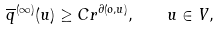Convert formula to latex. <formula><loc_0><loc_0><loc_500><loc_500>\overline { q } ^ { ( \infty ) } ( u ) \geq C r ^ { \partial ( o , u ) } , \quad u \in V ,</formula> 